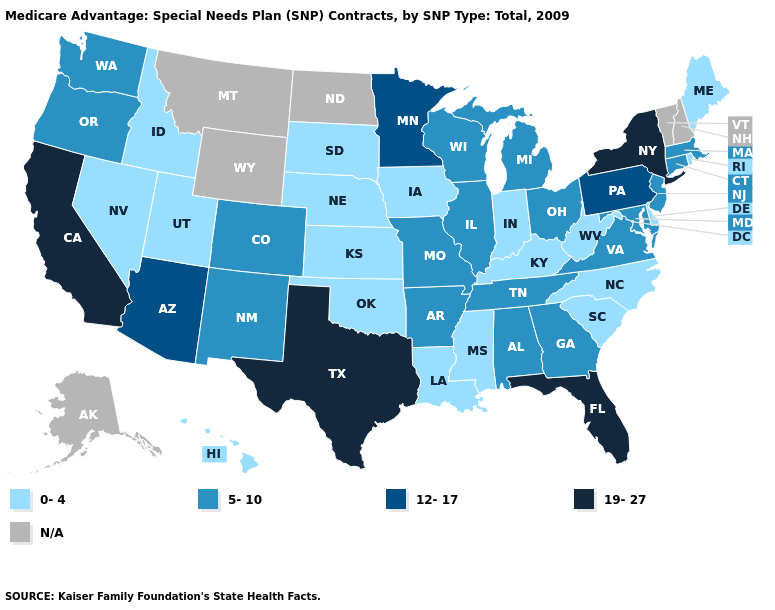Is the legend a continuous bar?
Concise answer only. No. What is the lowest value in the South?
Quick response, please. 0-4. Is the legend a continuous bar?
Write a very short answer. No. Does Arkansas have the lowest value in the South?
Keep it brief. No. Among the states that border Iowa , does Nebraska have the lowest value?
Keep it brief. Yes. How many symbols are there in the legend?
Concise answer only. 5. What is the lowest value in the USA?
Be succinct. 0-4. What is the value of North Carolina?
Short answer required. 0-4. What is the value of Oregon?
Answer briefly. 5-10. Does Florida have the highest value in the USA?
Give a very brief answer. Yes. What is the highest value in the USA?
Write a very short answer. 19-27. Does Rhode Island have the lowest value in the Northeast?
Give a very brief answer. Yes. What is the value of Florida?
Be succinct. 19-27. Is the legend a continuous bar?
Be succinct. No. 